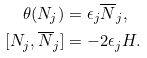<formula> <loc_0><loc_0><loc_500><loc_500>\theta ( N _ { j } ) & = \epsilon _ { j } \overline { N } _ { j } , \\ [ N _ { j } , \overline { N } _ { j } ] & = - 2 \epsilon _ { j } H .</formula> 